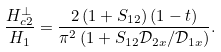<formula> <loc_0><loc_0><loc_500><loc_500>\frac { H _ { c 2 } ^ { \perp } } { H _ { 1 } } = \frac { 2 \left ( 1 + S _ { 1 2 } \right ) ( 1 - t ) } { \pi ^ { 2 } \left ( 1 + S _ { 1 2 } \mathcal { D } _ { 2 x } / \mathcal { D } _ { 1 x } \right ) } .</formula> 